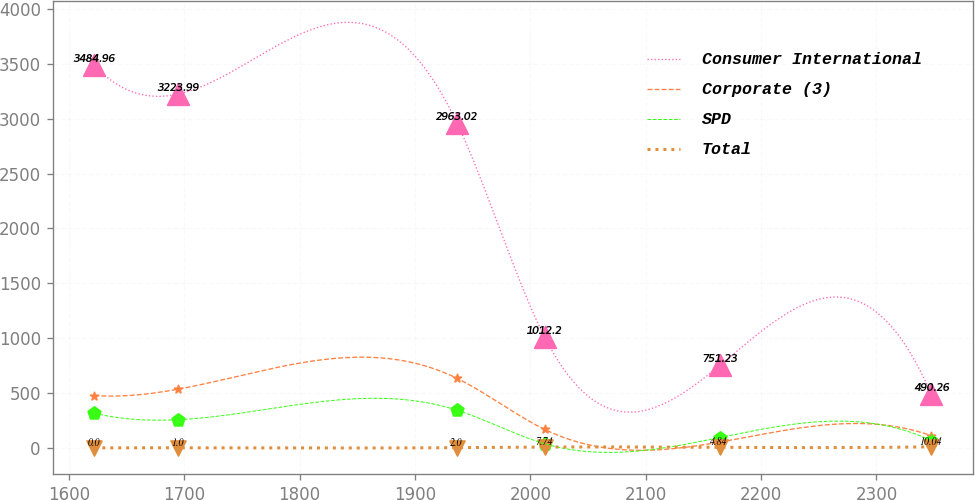Convert chart. <chart><loc_0><loc_0><loc_500><loc_500><line_chart><ecel><fcel>Consumer International<fcel>Corporate (3)<fcel>SPD<fcel>Total<nl><fcel>1622.04<fcel>3484.96<fcel>476.9<fcel>315.71<fcel>0<nl><fcel>1694.6<fcel>3223.99<fcel>535.07<fcel>256.67<fcel>1<nl><fcel>1936.31<fcel>2963.02<fcel>634.5<fcel>343.88<fcel>2<nl><fcel>2012.31<fcel>1012.2<fcel>169.16<fcel>38.09<fcel>7.74<nl><fcel>2164.21<fcel>751.23<fcel>52.82<fcel>94.41<fcel>4.84<nl><fcel>2347.64<fcel>490.26<fcel>110.99<fcel>66.25<fcel>10.04<nl></chart> 